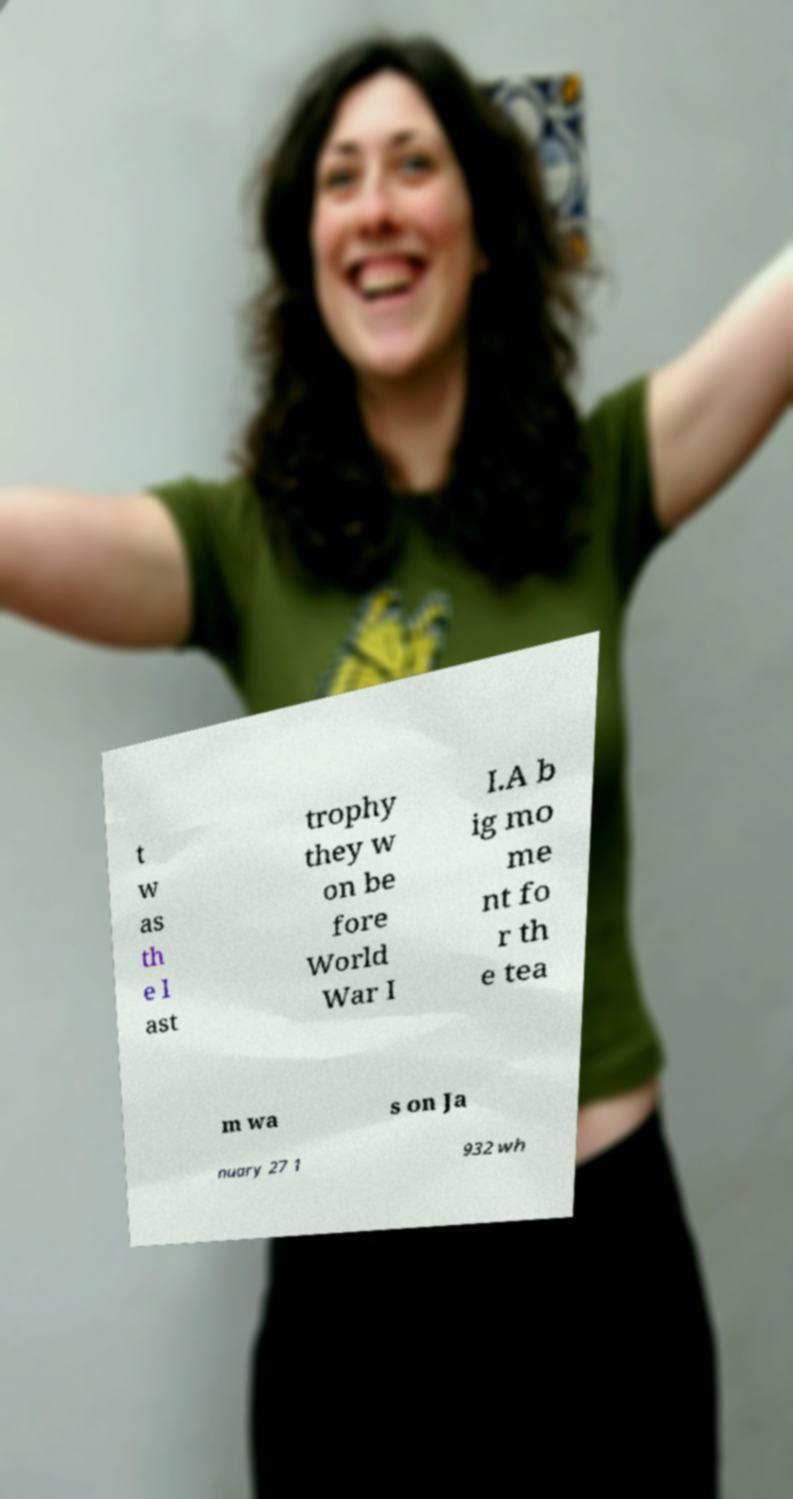Please read and relay the text visible in this image. What does it say? t w as th e l ast trophy they w on be fore World War I I.A b ig mo me nt fo r th e tea m wa s on Ja nuary 27 1 932 wh 